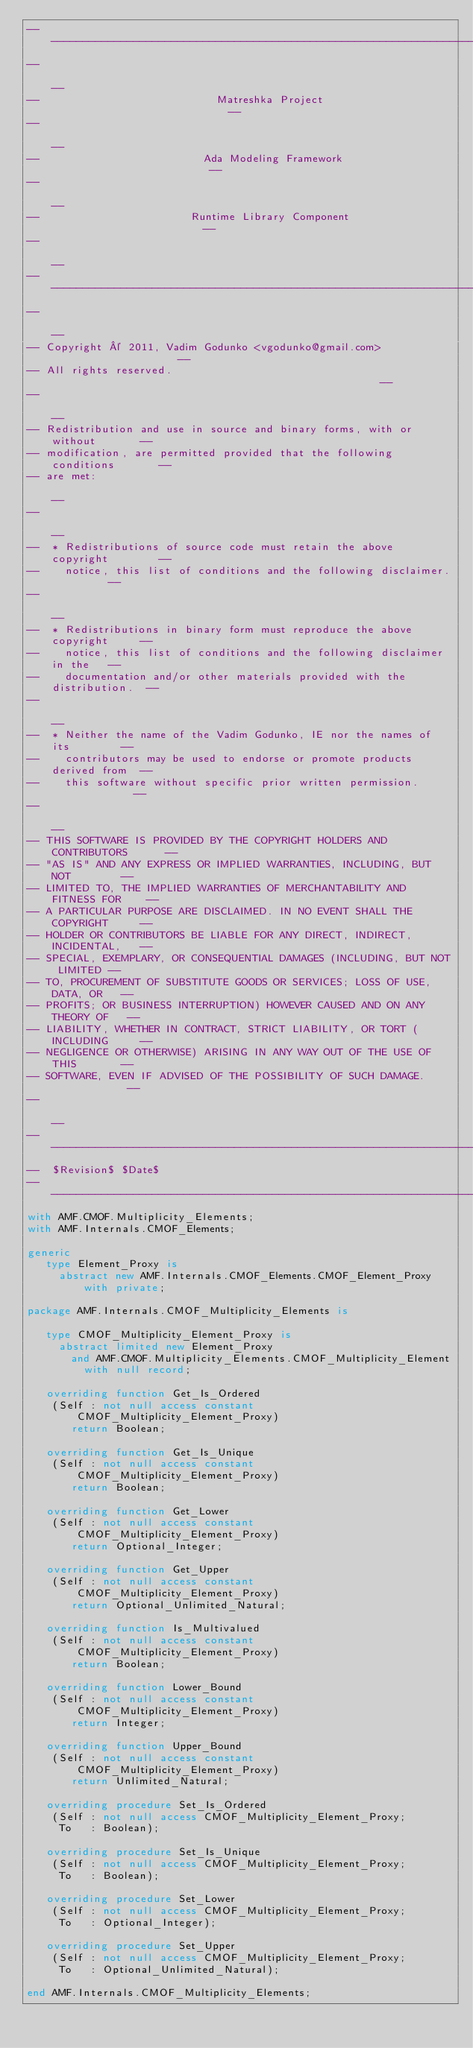Convert code to text. <code><loc_0><loc_0><loc_500><loc_500><_Ada_>------------------------------------------------------------------------------
--                                                                          --
--                            Matreshka Project                             --
--                                                                          --
--                          Ada Modeling Framework                          --
--                                                                          --
--                        Runtime Library Component                         --
--                                                                          --
------------------------------------------------------------------------------
--                                                                          --
-- Copyright © 2011, Vadim Godunko <vgodunko@gmail.com>                     --
-- All rights reserved.                                                     --
--                                                                          --
-- Redistribution and use in source and binary forms, with or without       --
-- modification, are permitted provided that the following conditions       --
-- are met:                                                                 --
--                                                                          --
--  * Redistributions of source code must retain the above copyright        --
--    notice, this list of conditions and the following disclaimer.         --
--                                                                          --
--  * Redistributions in binary form must reproduce the above copyright     --
--    notice, this list of conditions and the following disclaimer in the   --
--    documentation and/or other materials provided with the distribution.  --
--                                                                          --
--  * Neither the name of the Vadim Godunko, IE nor the names of its        --
--    contributors may be used to endorse or promote products derived from  --
--    this software without specific prior written permission.              --
--                                                                          --
-- THIS SOFTWARE IS PROVIDED BY THE COPYRIGHT HOLDERS AND CONTRIBUTORS      --
-- "AS IS" AND ANY EXPRESS OR IMPLIED WARRANTIES, INCLUDING, BUT NOT        --
-- LIMITED TO, THE IMPLIED WARRANTIES OF MERCHANTABILITY AND FITNESS FOR    --
-- A PARTICULAR PURPOSE ARE DISCLAIMED. IN NO EVENT SHALL THE COPYRIGHT     --
-- HOLDER OR CONTRIBUTORS BE LIABLE FOR ANY DIRECT, INDIRECT, INCIDENTAL,   --
-- SPECIAL, EXEMPLARY, OR CONSEQUENTIAL DAMAGES (INCLUDING, BUT NOT LIMITED --
-- TO, PROCUREMENT OF SUBSTITUTE GOODS OR SERVICES; LOSS OF USE, DATA, OR   --
-- PROFITS; OR BUSINESS INTERRUPTION) HOWEVER CAUSED AND ON ANY THEORY OF   --
-- LIABILITY, WHETHER IN CONTRACT, STRICT LIABILITY, OR TORT (INCLUDING     --
-- NEGLIGENCE OR OTHERWISE) ARISING IN ANY WAY OUT OF THE USE OF THIS       --
-- SOFTWARE, EVEN IF ADVISED OF THE POSSIBILITY OF SUCH DAMAGE.             --
--                                                                          --
------------------------------------------------------------------------------
--  $Revision$ $Date$
------------------------------------------------------------------------------
with AMF.CMOF.Multiplicity_Elements;
with AMF.Internals.CMOF_Elements;

generic
   type Element_Proxy is
     abstract new AMF.Internals.CMOF_Elements.CMOF_Element_Proxy with private;

package AMF.Internals.CMOF_Multiplicity_Elements is

   type CMOF_Multiplicity_Element_Proxy is
     abstract limited new Element_Proxy
       and AMF.CMOF.Multiplicity_Elements.CMOF_Multiplicity_Element
         with null record;

   overriding function Get_Is_Ordered
    (Self : not null access constant CMOF_Multiplicity_Element_Proxy)
       return Boolean;

   overriding function Get_Is_Unique
    (Self : not null access constant CMOF_Multiplicity_Element_Proxy)
       return Boolean;

   overriding function Get_Lower
    (Self : not null access constant CMOF_Multiplicity_Element_Proxy)
       return Optional_Integer;

   overriding function Get_Upper
    (Self : not null access constant CMOF_Multiplicity_Element_Proxy)
       return Optional_Unlimited_Natural;

   overriding function Is_Multivalued
    (Self : not null access constant CMOF_Multiplicity_Element_Proxy)
       return Boolean;

   overriding function Lower_Bound
    (Self : not null access constant CMOF_Multiplicity_Element_Proxy)
       return Integer;

   overriding function Upper_Bound
    (Self : not null access constant CMOF_Multiplicity_Element_Proxy)
       return Unlimited_Natural;

   overriding procedure Set_Is_Ordered
    (Self : not null access CMOF_Multiplicity_Element_Proxy;
     To   : Boolean);

   overriding procedure Set_Is_Unique
    (Self : not null access CMOF_Multiplicity_Element_Proxy;
     To   : Boolean);

   overriding procedure Set_Lower
    (Self : not null access CMOF_Multiplicity_Element_Proxy;
     To   : Optional_Integer);

   overriding procedure Set_Upper
    (Self : not null access CMOF_Multiplicity_Element_Proxy;
     To   : Optional_Unlimited_Natural);

end AMF.Internals.CMOF_Multiplicity_Elements;
</code> 